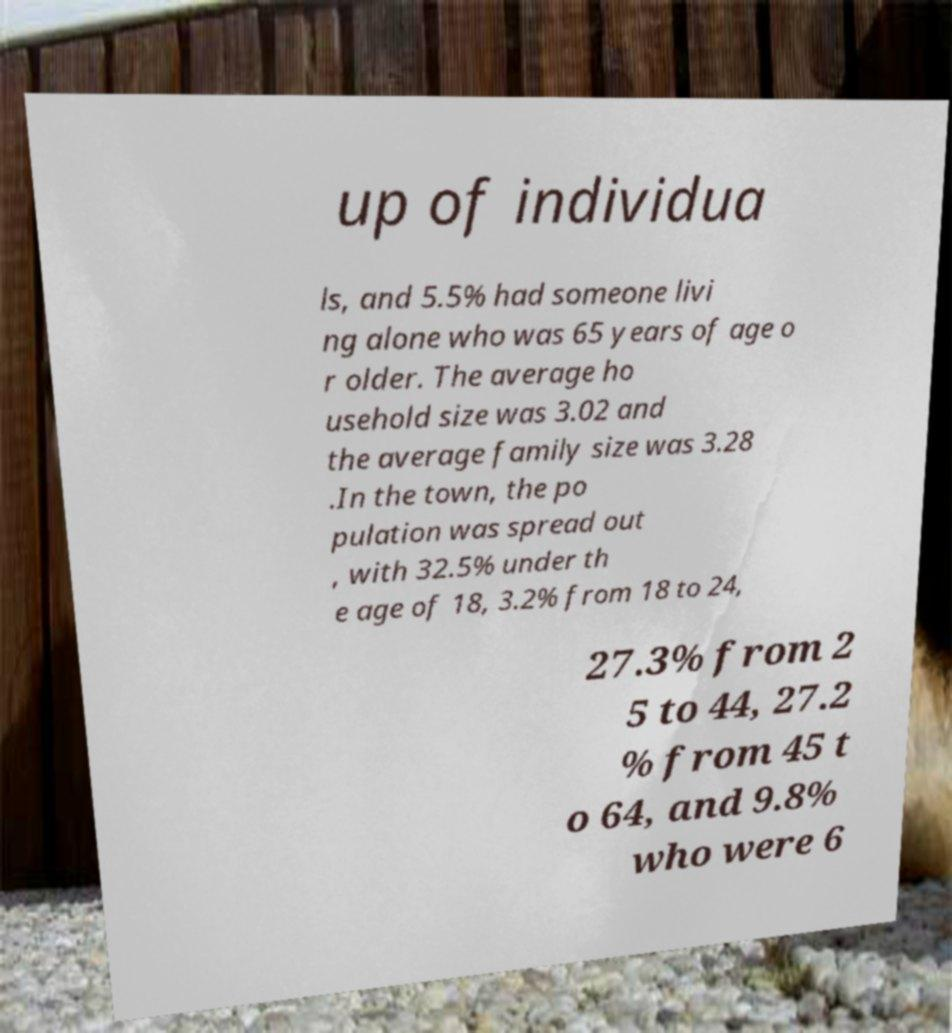What messages or text are displayed in this image? I need them in a readable, typed format. up of individua ls, and 5.5% had someone livi ng alone who was 65 years of age o r older. The average ho usehold size was 3.02 and the average family size was 3.28 .In the town, the po pulation was spread out , with 32.5% under th e age of 18, 3.2% from 18 to 24, 27.3% from 2 5 to 44, 27.2 % from 45 t o 64, and 9.8% who were 6 